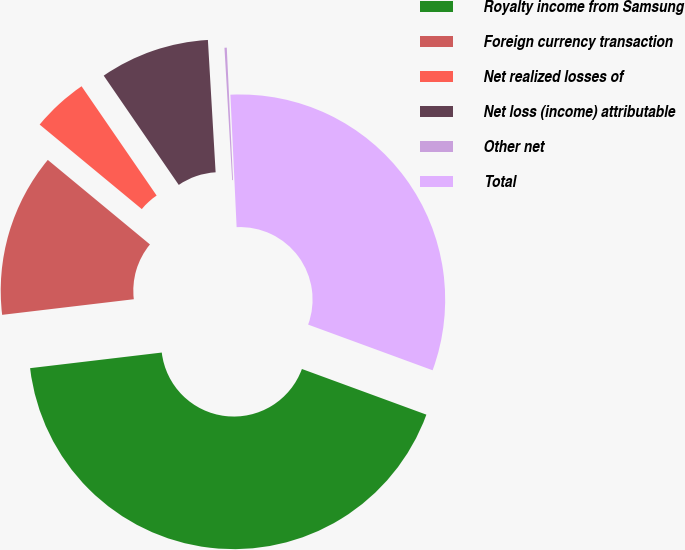Convert chart to OTSL. <chart><loc_0><loc_0><loc_500><loc_500><pie_chart><fcel>Royalty income from Samsung<fcel>Foreign currency transaction<fcel>Net realized losses of<fcel>Net loss (income) attributable<fcel>Other net<fcel>Total<nl><fcel>42.52%<fcel>12.88%<fcel>4.42%<fcel>8.65%<fcel>0.18%<fcel>31.34%<nl></chart> 